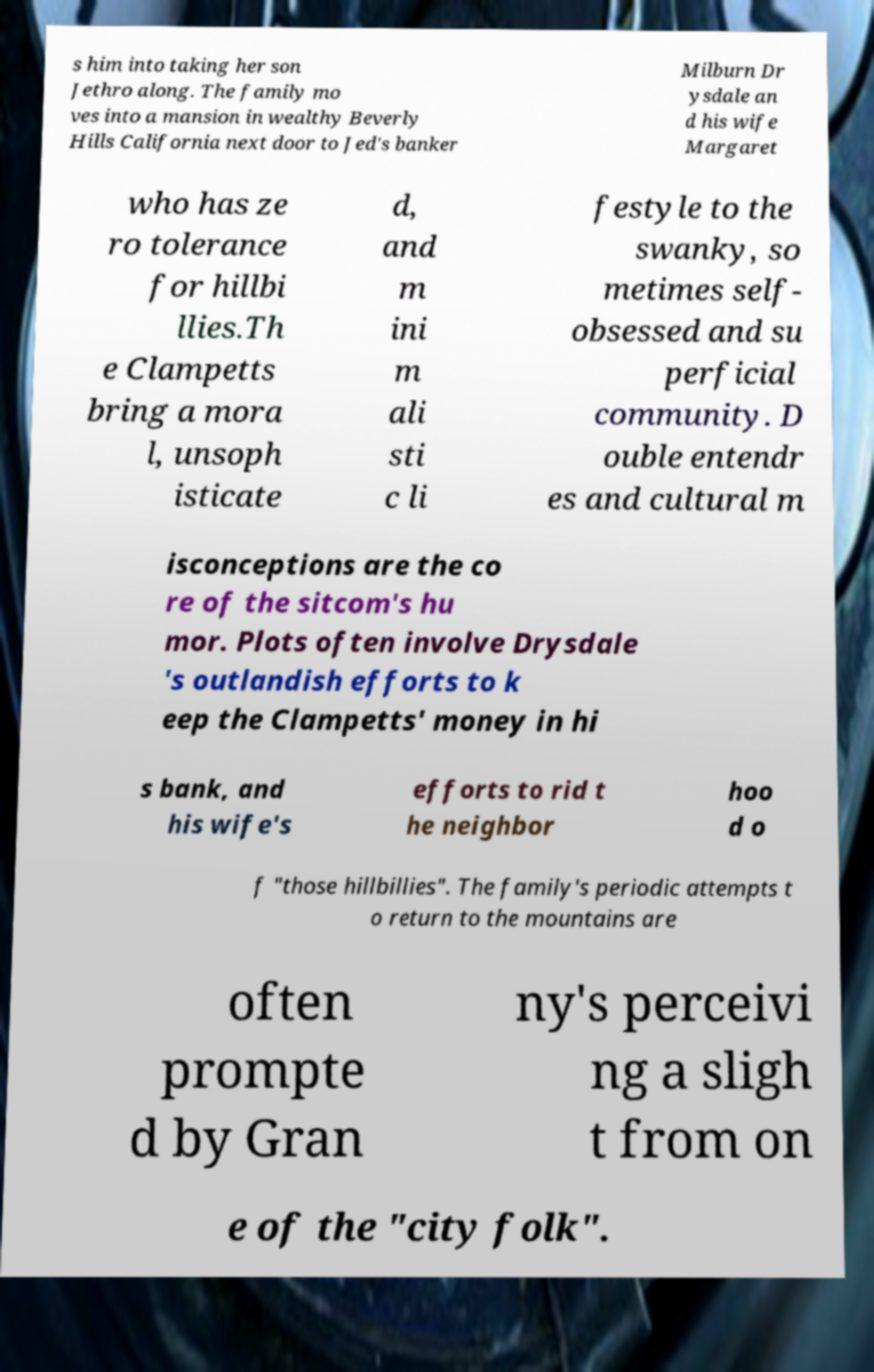Could you extract and type out the text from this image? s him into taking her son Jethro along. The family mo ves into a mansion in wealthy Beverly Hills California next door to Jed's banker Milburn Dr ysdale an d his wife Margaret who has ze ro tolerance for hillbi llies.Th e Clampetts bring a mora l, unsoph isticate d, and m ini m ali sti c li festyle to the swanky, so metimes self- obsessed and su perficial community. D ouble entendr es and cultural m isconceptions are the co re of the sitcom's hu mor. Plots often involve Drysdale 's outlandish efforts to k eep the Clampetts' money in hi s bank, and his wife's efforts to rid t he neighbor hoo d o f "those hillbillies". The family's periodic attempts t o return to the mountains are often prompte d by Gran ny's perceivi ng a sligh t from on e of the "city folk". 